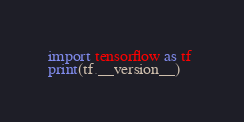Convert code to text. <code><loc_0><loc_0><loc_500><loc_500><_Python_>import tensorflow as tf 
print(tf.__version__)
</code> 